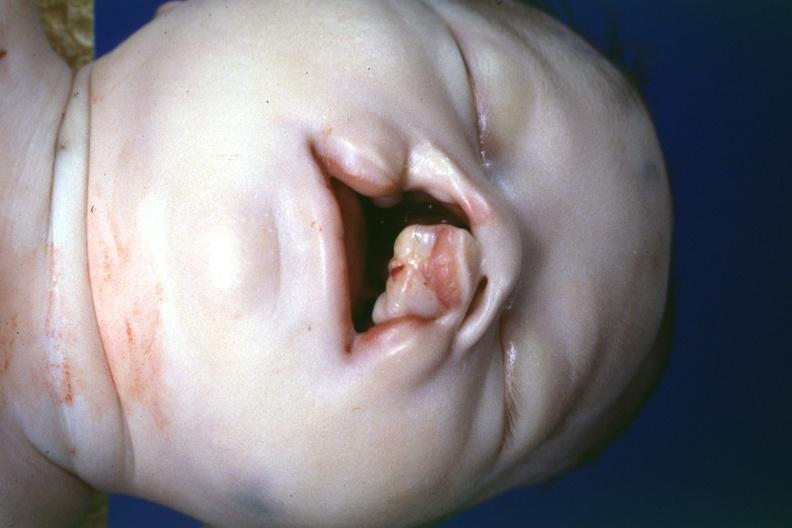s face present?
Answer the question using a single word or phrase. Yes 